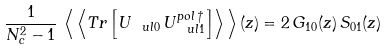<formula> <loc_0><loc_0><loc_500><loc_500>\frac { 1 } { N _ { c } ^ { 2 } - 1 } \, \left \langle \, \left \langle T r \left [ U _ { \ u l { 0 } } \, U _ { \ u l { 1 } } ^ { p o l \, \dagger } \right ] \right \rangle \, \right \rangle ( z ) = 2 \, { G } _ { 1 0 } ( z ) \, S _ { 0 1 } ( z )</formula> 